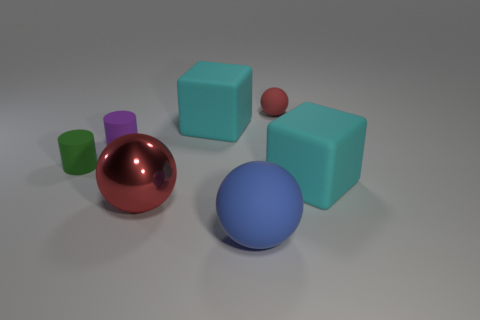Add 1 tiny shiny spheres. How many objects exist? 8 Subtract all blocks. How many objects are left? 5 Subtract all big green things. Subtract all cyan blocks. How many objects are left? 5 Add 2 small rubber cylinders. How many small rubber cylinders are left? 4 Add 1 red metallic things. How many red metallic things exist? 2 Subtract 0 yellow cylinders. How many objects are left? 7 